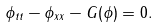<formula> <loc_0><loc_0><loc_500><loc_500>\phi _ { t t } - \phi _ { x x } - G ( \phi ) = 0 .</formula> 